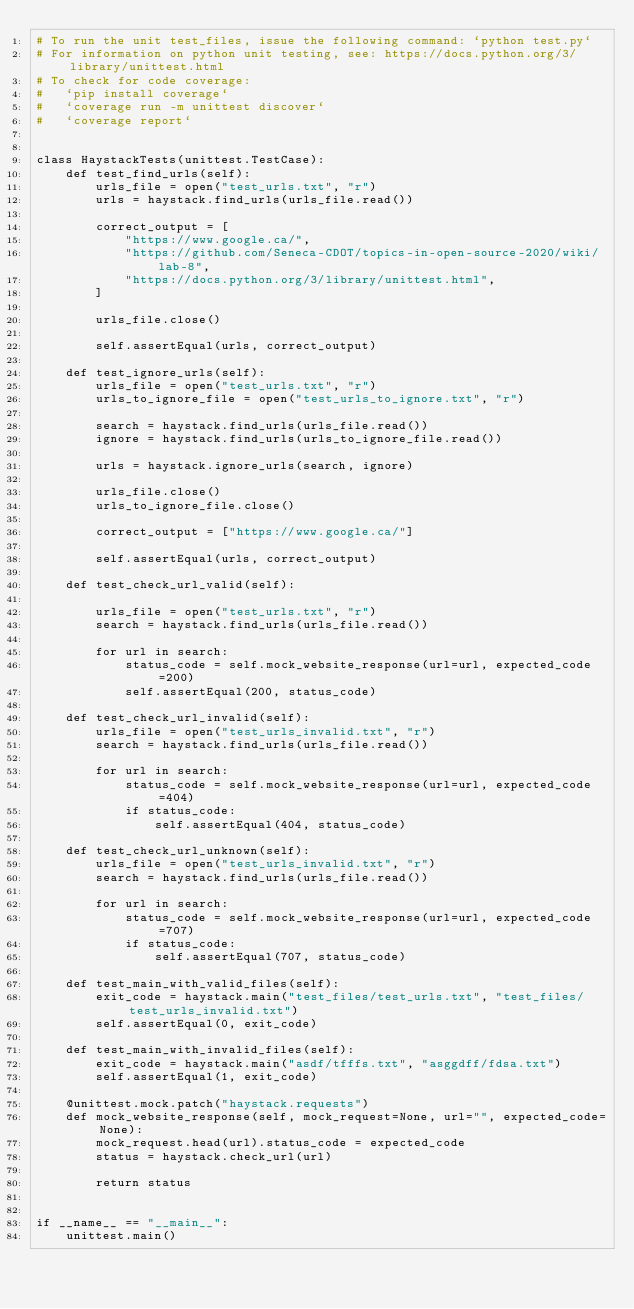Convert code to text. <code><loc_0><loc_0><loc_500><loc_500><_Python_># To run the unit test_files, issue the following command: `python test.py`
# For information on python unit testing, see: https://docs.python.org/3/library/unittest.html
# To check for code coverage:
#   `pip install coverage`
#   `coverage run -m unittest discover`
#   `coverage report`


class HaystackTests(unittest.TestCase):
    def test_find_urls(self):
        urls_file = open("test_urls.txt", "r")
        urls = haystack.find_urls(urls_file.read())

        correct_output = [
            "https://www.google.ca/",
            "https://github.com/Seneca-CDOT/topics-in-open-source-2020/wiki/lab-8",
            "https://docs.python.org/3/library/unittest.html",
        ]

        urls_file.close()

        self.assertEqual(urls, correct_output)

    def test_ignore_urls(self):
        urls_file = open("test_urls.txt", "r")
        urls_to_ignore_file = open("test_urls_to_ignore.txt", "r")

        search = haystack.find_urls(urls_file.read())
        ignore = haystack.find_urls(urls_to_ignore_file.read())

        urls = haystack.ignore_urls(search, ignore)

        urls_file.close()
        urls_to_ignore_file.close()

        correct_output = ["https://www.google.ca/"]

        self.assertEqual(urls, correct_output)

    def test_check_url_valid(self):

        urls_file = open("test_urls.txt", "r")
        search = haystack.find_urls(urls_file.read())

        for url in search:
            status_code = self.mock_website_response(url=url, expected_code=200)
            self.assertEqual(200, status_code)

    def test_check_url_invalid(self):
        urls_file = open("test_urls_invalid.txt", "r")
        search = haystack.find_urls(urls_file.read())

        for url in search:
            status_code = self.mock_website_response(url=url, expected_code=404)
            if status_code:
                self.assertEqual(404, status_code)

    def test_check_url_unknown(self):
        urls_file = open("test_urls_invalid.txt", "r")
        search = haystack.find_urls(urls_file.read())

        for url in search:
            status_code = self.mock_website_response(url=url, expected_code=707)
            if status_code:
                self.assertEqual(707, status_code)

    def test_main_with_valid_files(self):
        exit_code = haystack.main("test_files/test_urls.txt", "test_files/test_urls_invalid.txt")
        self.assertEqual(0, exit_code)

    def test_main_with_invalid_files(self):
        exit_code = haystack.main("asdf/tfffs.txt", "asggdff/fdsa.txt")
        self.assertEqual(1, exit_code)

    @unittest.mock.patch("haystack.requests")
    def mock_website_response(self, mock_request=None, url="", expected_code=None):
        mock_request.head(url).status_code = expected_code
        status = haystack.check_url(url)

        return status


if __name__ == "__main__":
    unittest.main()
</code> 